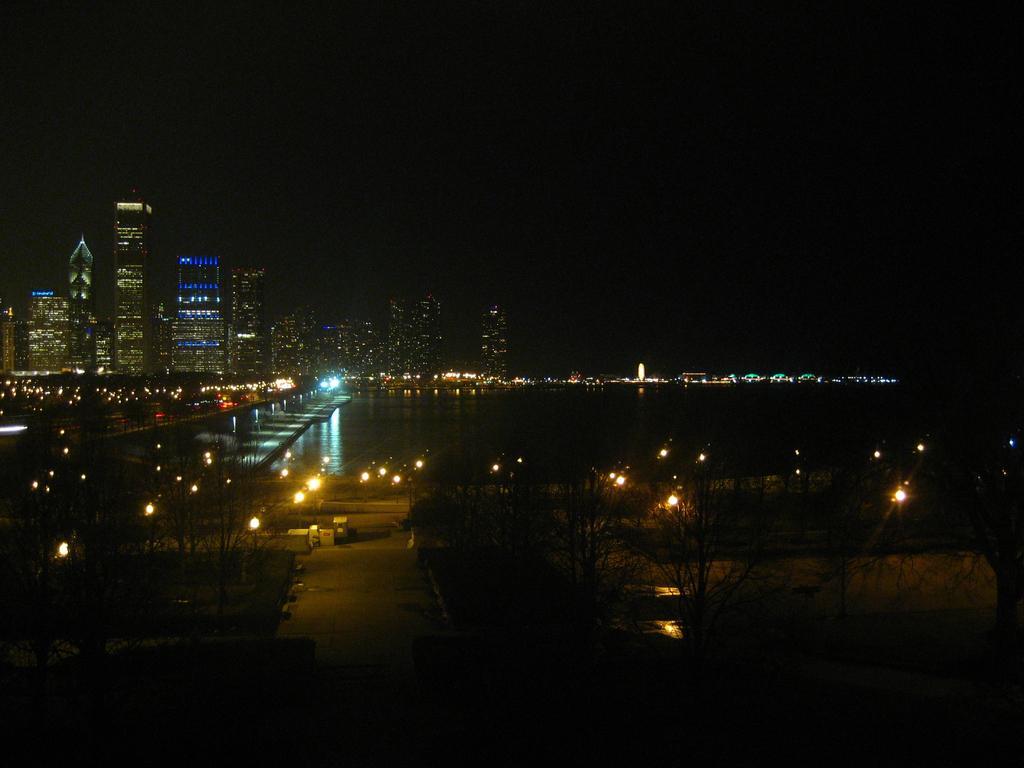Describe this image in one or two sentences. This image consists of trees, light poles, water, bridge, houses, buildings, towers and the sky. This image is taken may be during night. 